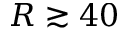Convert formula to latex. <formula><loc_0><loc_0><loc_500><loc_500>R \gtrsim 4 0</formula> 